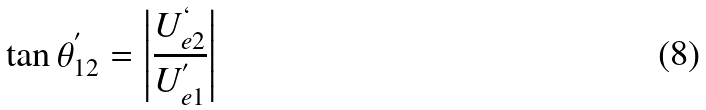Convert formula to latex. <formula><loc_0><loc_0><loc_500><loc_500>\tan \theta _ { 1 2 } ^ { ^ { \prime } } = \left | \frac { U _ { e 2 } ^ { ` } } { U _ { e 1 } ^ { ^ { \prime } } } \right |</formula> 